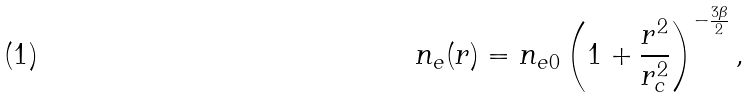Convert formula to latex. <formula><loc_0><loc_0><loc_500><loc_500>n _ { e } ( r ) = n _ { e 0 } \left ( 1 + \frac { r ^ { 2 } } { r ^ { 2 } _ { c } } \right ) ^ { - \frac { 3 \beta } { 2 } } ,</formula> 